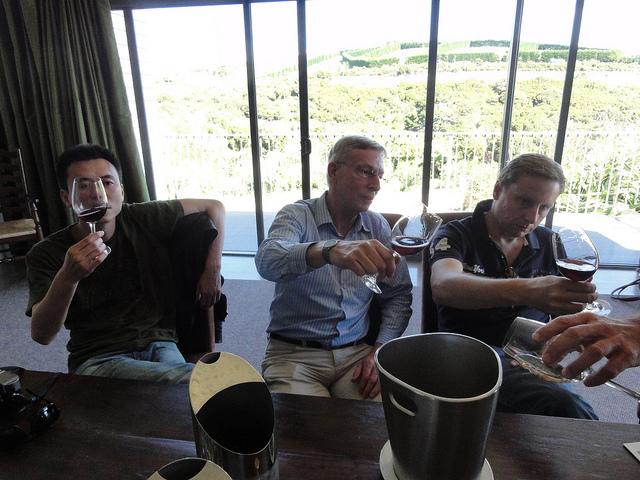Are these people casual wine drinkers?
Write a very short answer. No. How many glasses of wine are in the photo?
Write a very short answer. 3. How many faces are in the photo?
Write a very short answer. 3. What is on the table?
Write a very short answer. Cups. 